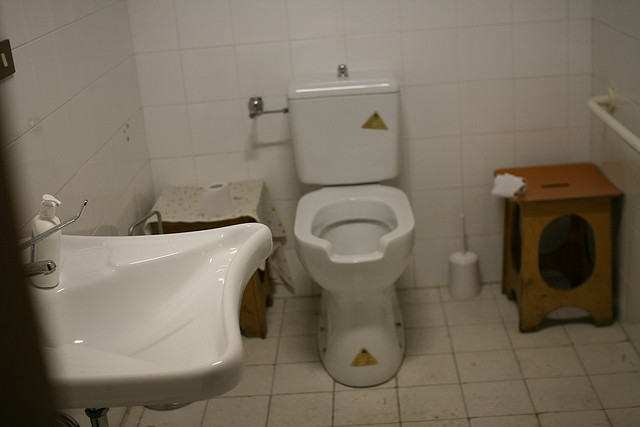How many sinks are in this room? 1 